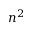<formula> <loc_0><loc_0><loc_500><loc_500>n ^ { 2 }</formula> 